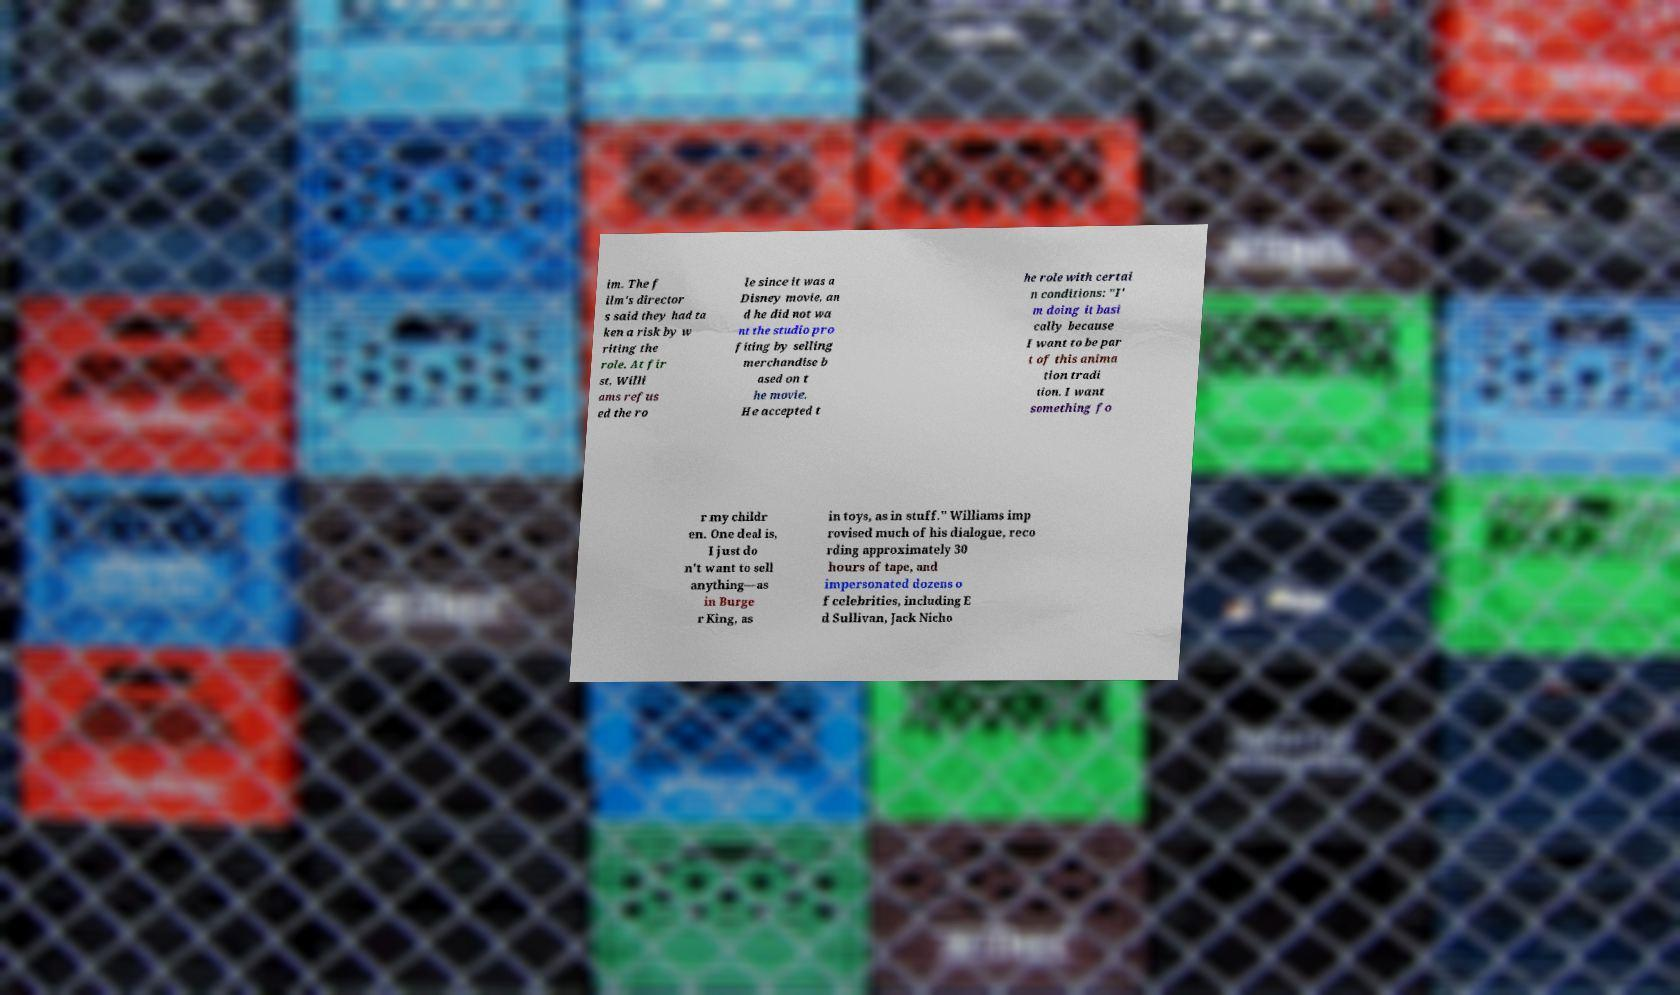Could you extract and type out the text from this image? im. The f ilm's director s said they had ta ken a risk by w riting the role. At fir st, Willi ams refus ed the ro le since it was a Disney movie, an d he did not wa nt the studio pro fiting by selling merchandise b ased on t he movie. He accepted t he role with certai n conditions: "I' m doing it basi cally because I want to be par t of this anima tion tradi tion. I want something fo r my childr en. One deal is, I just do n't want to sell anything—as in Burge r King, as in toys, as in stuff." Williams imp rovised much of his dialogue, reco rding approximately 30 hours of tape, and impersonated dozens o f celebrities, including E d Sullivan, Jack Nicho 